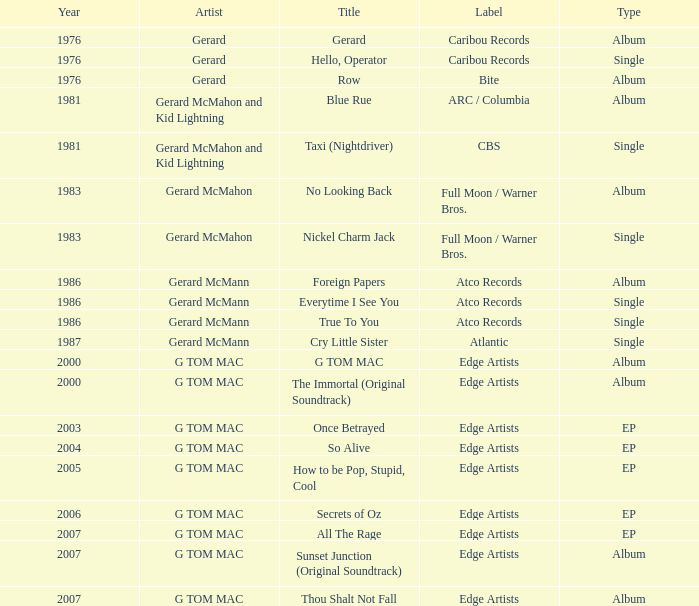Can you identify the title having an episode type and a year exceeding 2003? So Alive, How to be Pop, Stupid, Cool, Secrets of Oz, All The Rage. 